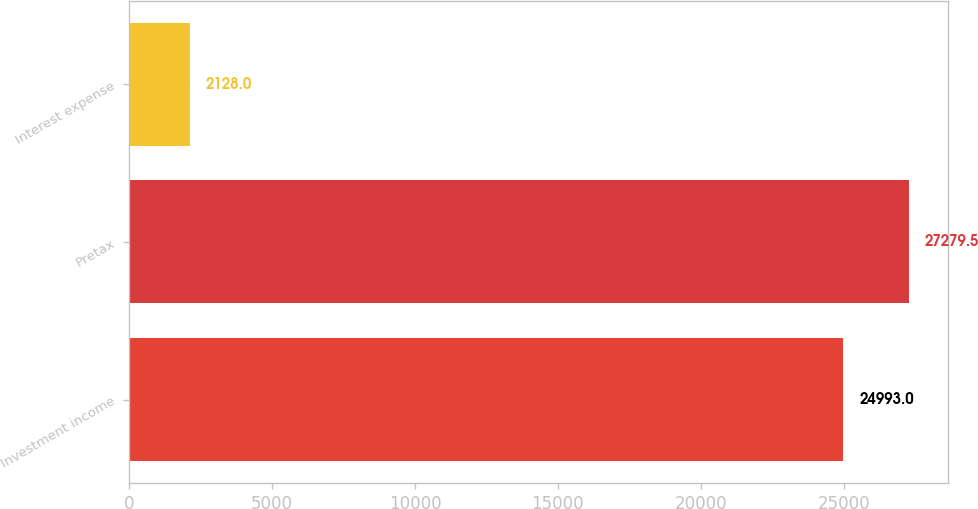Convert chart. <chart><loc_0><loc_0><loc_500><loc_500><bar_chart><fcel>Investment income<fcel>Pretax<fcel>Interest expense<nl><fcel>24993<fcel>27279.5<fcel>2128<nl></chart> 